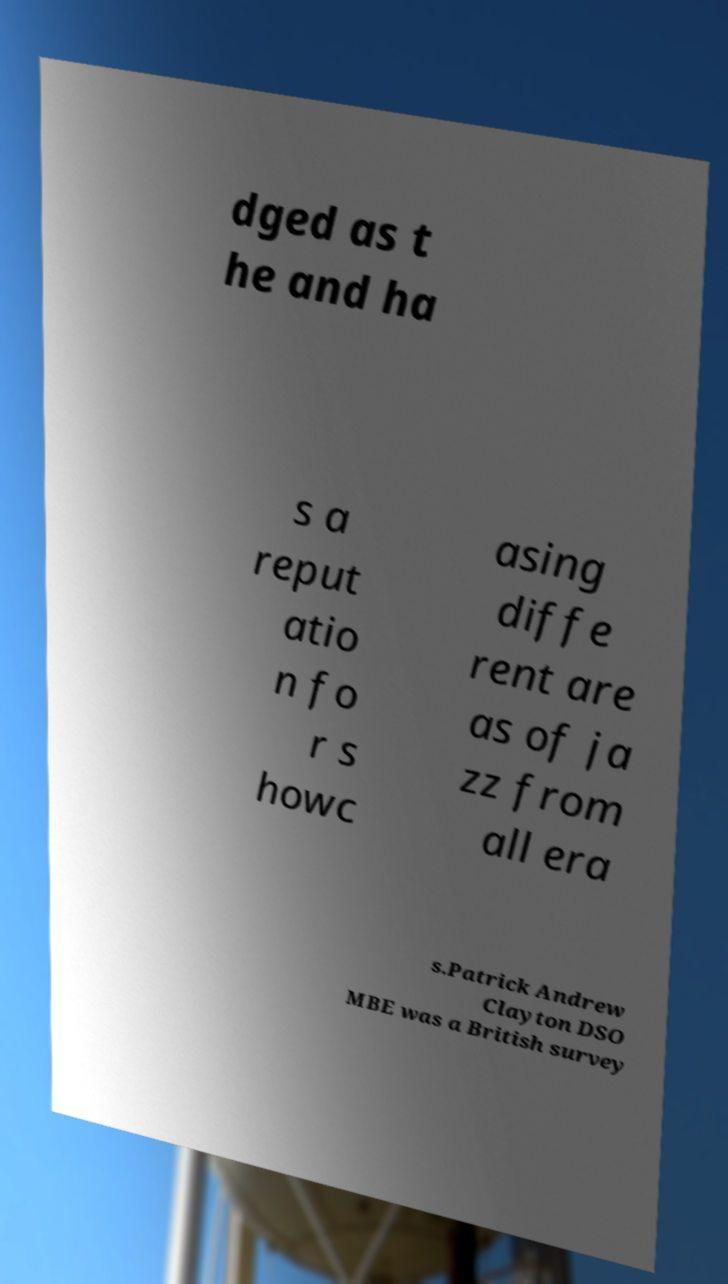Can you accurately transcribe the text from the provided image for me? dged as t he and ha s a reput atio n fo r s howc asing diffe rent are as of ja zz from all era s.Patrick Andrew Clayton DSO MBE was a British survey 